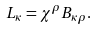<formula> <loc_0><loc_0><loc_500><loc_500>L _ { \kappa } = \chi ^ { \rho } B _ { \kappa \rho } .</formula> 